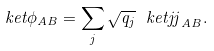Convert formula to latex. <formula><loc_0><loc_0><loc_500><loc_500>\ k e t { \phi } _ { A B } = \sum _ { j } \sqrt { q _ { j } } \ k e t { j j } _ { A B } .</formula> 